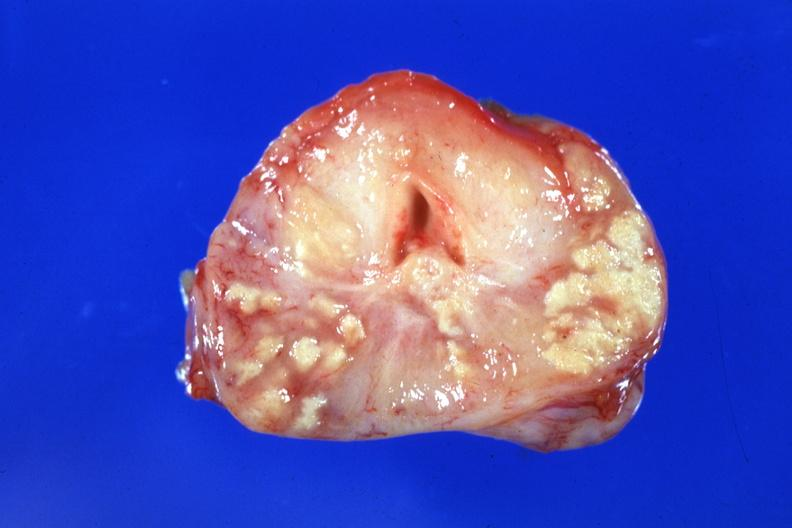what is present?
Answer the question using a single word or phrase. Tuberculosis 